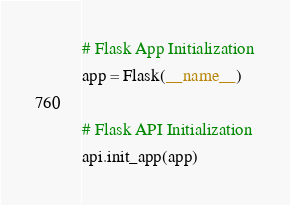Convert code to text. <code><loc_0><loc_0><loc_500><loc_500><_Python_>
# Flask App Initialization
app = Flask(__name__)

# Flask API Initialization
api.init_app(app)
</code> 